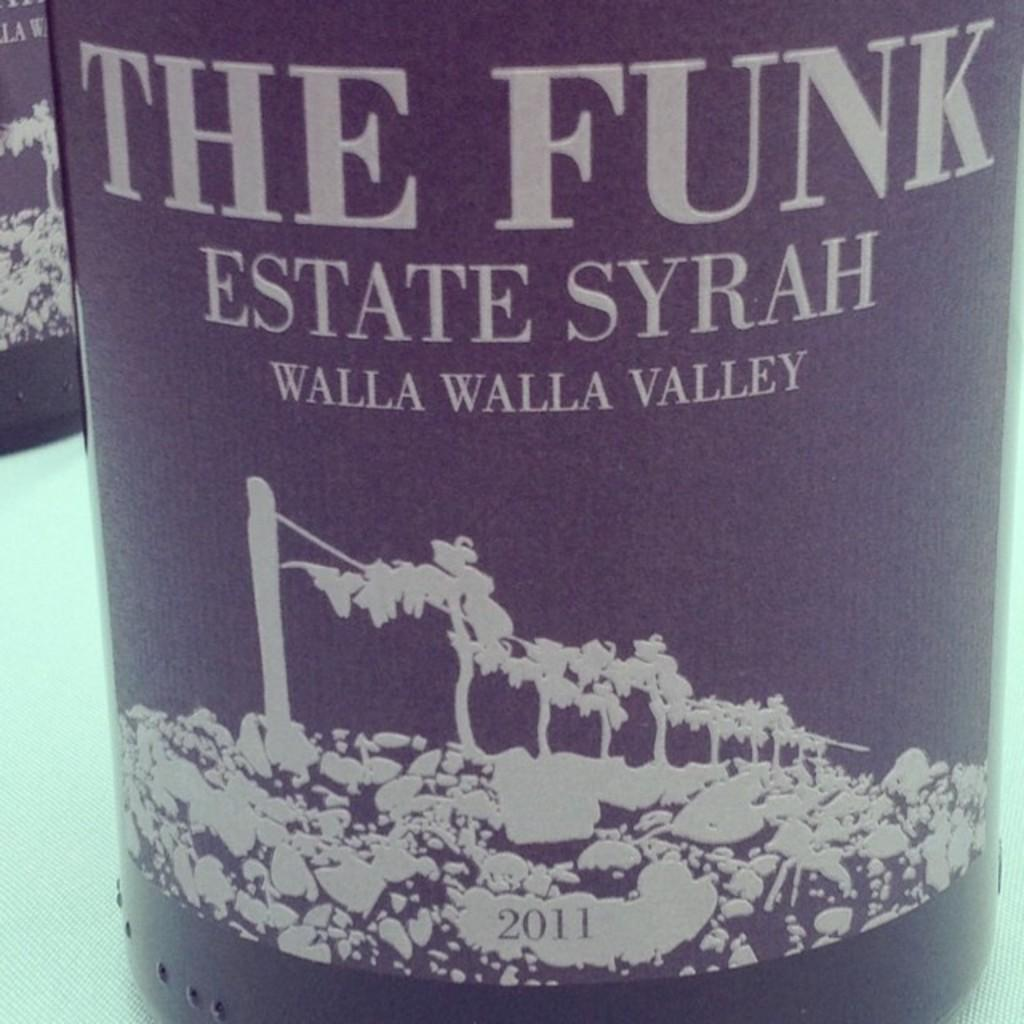What is the color of the glass bottle in the image? The glass bottle in the image is black. What is the bottle placed on in the image? The bottle is placed on a white table. What words are written on the bottle? The words "THE FUNK" are written on the bottle. Are there any other bottles in the image? Yes, there is another glass bottle in the image. What subject is being taught in the image? There is no indication of teaching or any educational activity in the image. 